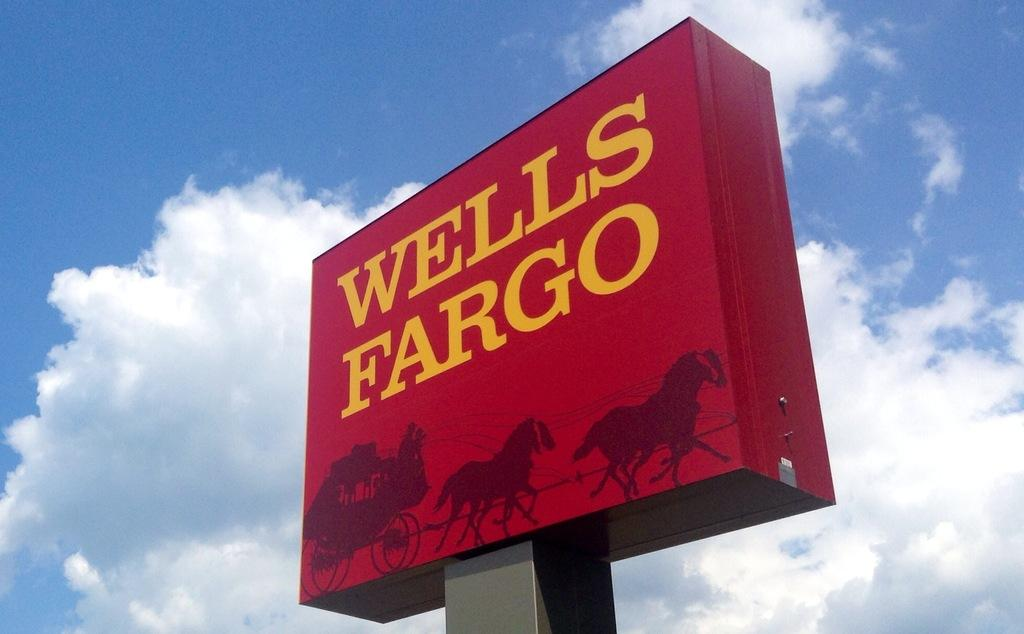<image>
Create a compact narrative representing the image presented. A elevated advertising sign for a bank called Wells Fargo 